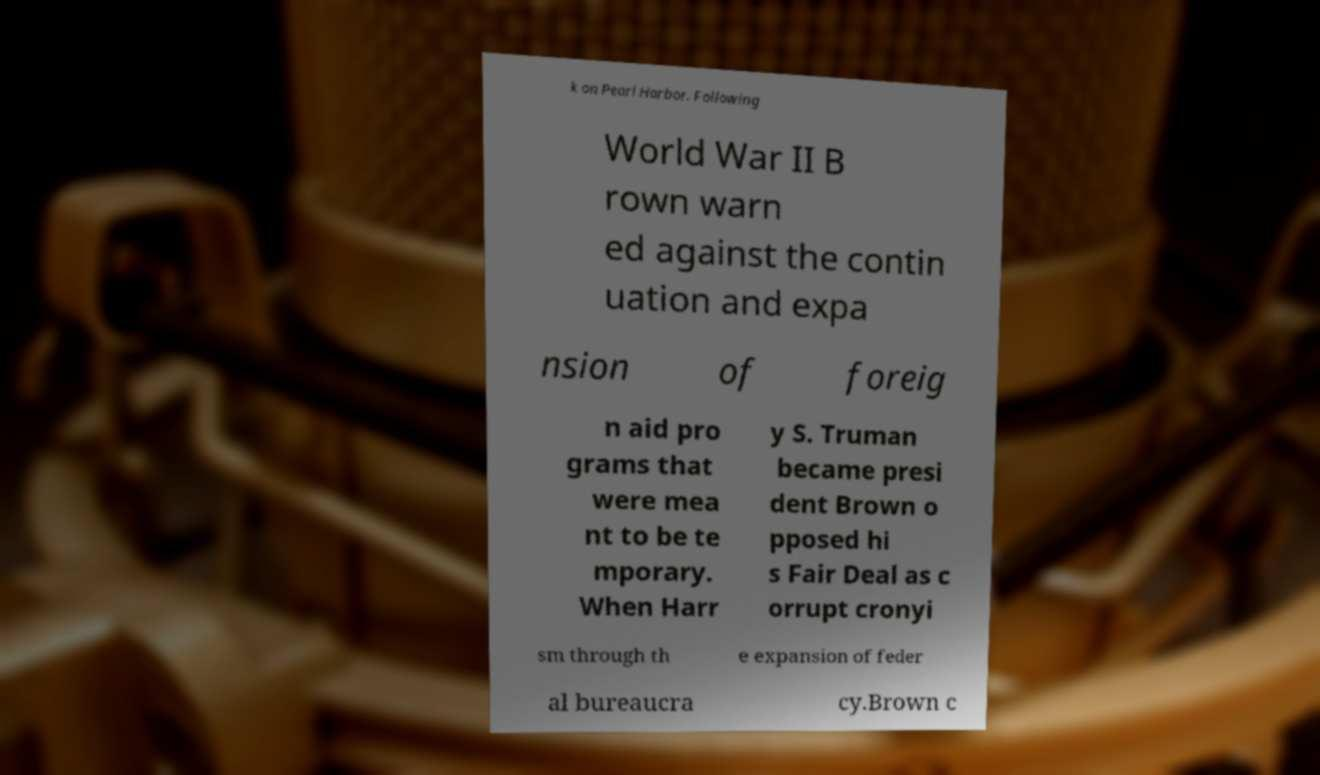Please identify and transcribe the text found in this image. k on Pearl Harbor. Following World War II B rown warn ed against the contin uation and expa nsion of foreig n aid pro grams that were mea nt to be te mporary. When Harr y S. Truman became presi dent Brown o pposed hi s Fair Deal as c orrupt cronyi sm through th e expansion of feder al bureaucra cy.Brown c 